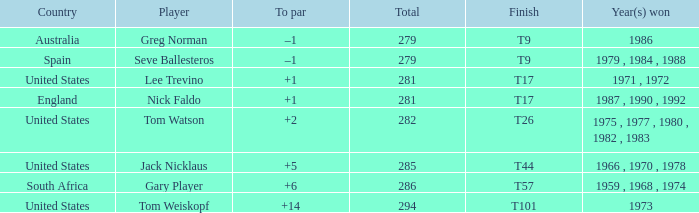Which country had a total of 282? United States. 